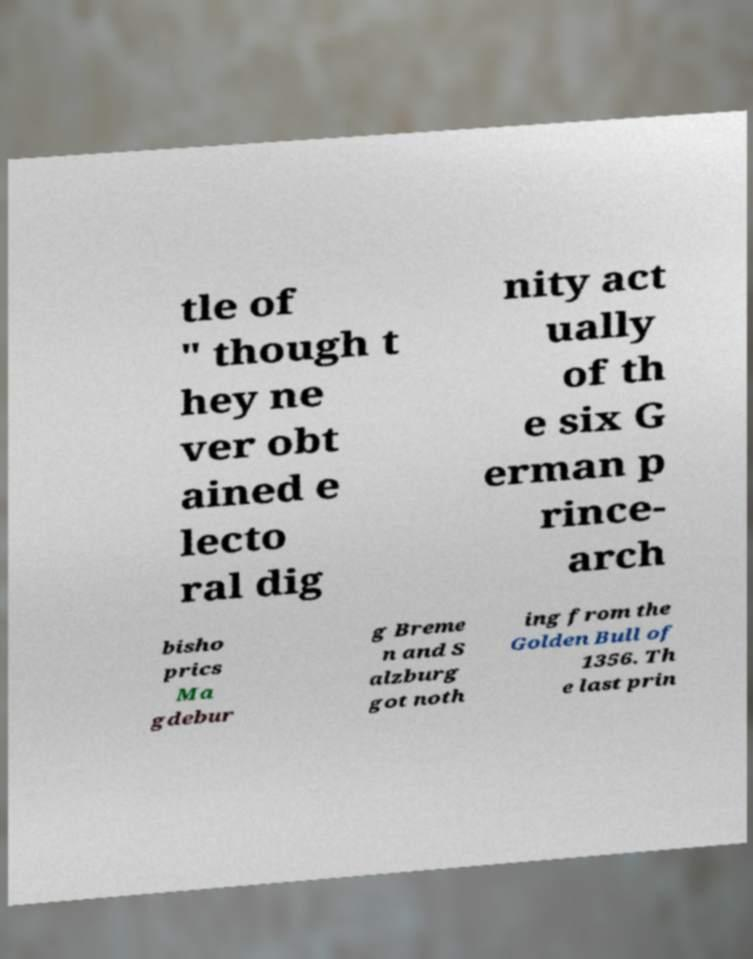Can you read and provide the text displayed in the image?This photo seems to have some interesting text. Can you extract and type it out for me? tle of " though t hey ne ver obt ained e lecto ral dig nity act ually of th e six G erman p rince- arch bisho prics Ma gdebur g Breme n and S alzburg got noth ing from the Golden Bull of 1356. Th e last prin 